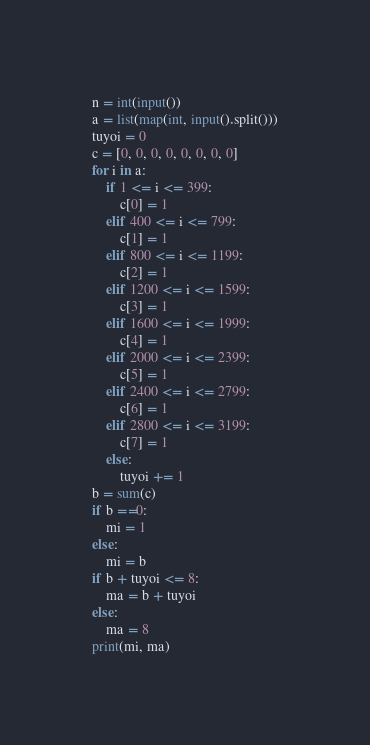Convert code to text. <code><loc_0><loc_0><loc_500><loc_500><_Python_>n = int(input())
a = list(map(int, input().split()))
tuyoi = 0
c = [0, 0, 0, 0, 0, 0, 0, 0]
for i in a:
    if 1 <= i <= 399:
        c[0] = 1
    elif 400 <= i <= 799:
        c[1] = 1
    elif 800 <= i <= 1199:
        c[2] = 1
    elif 1200 <= i <= 1599:
        c[3] = 1
    elif 1600 <= i <= 1999:
        c[4] = 1
    elif 2000 <= i <= 2399:
        c[5] = 1
    elif 2400 <= i <= 2799:
        c[6] = 1
    elif 2800 <= i <= 3199:
        c[7] = 1
    else:
        tuyoi += 1
b = sum(c)
if b ==0:
    mi = 1
else:
    mi = b
if b + tuyoi <= 8:
    ma = b + tuyoi
else:
    ma = 8
print(mi, ma)
</code> 